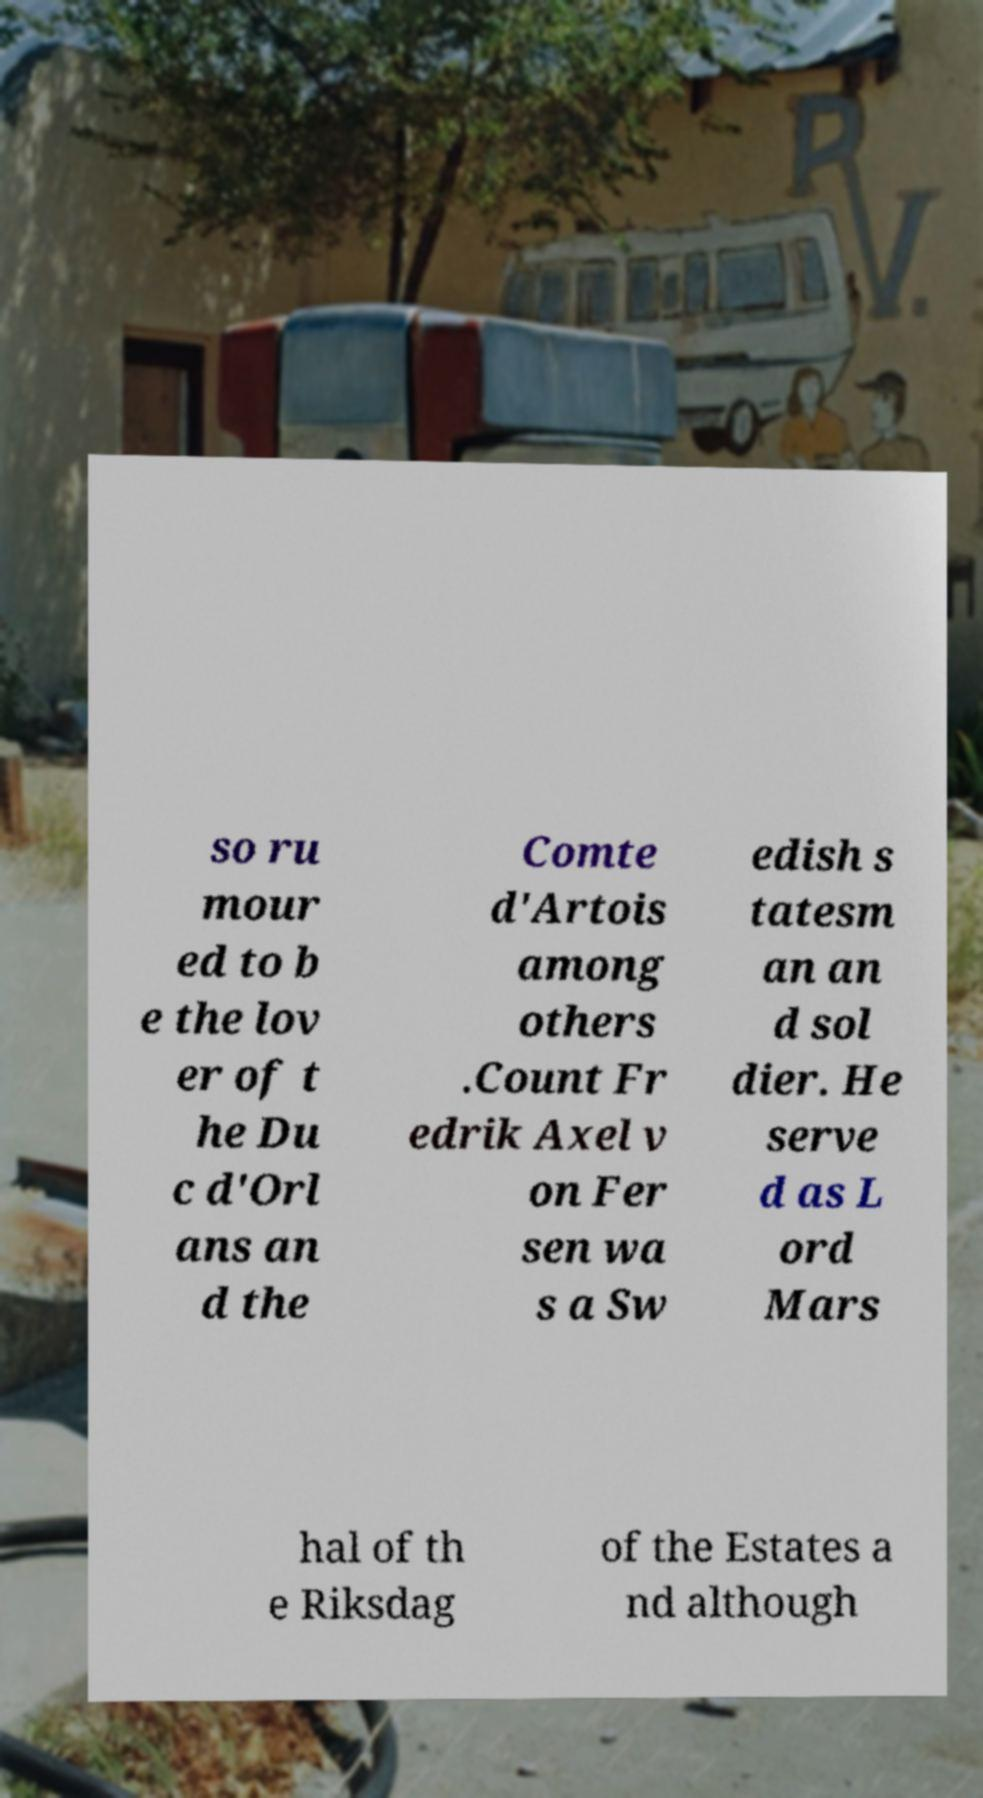Please identify and transcribe the text found in this image. so ru mour ed to b e the lov er of t he Du c d'Orl ans an d the Comte d'Artois among others .Count Fr edrik Axel v on Fer sen wa s a Sw edish s tatesm an an d sol dier. He serve d as L ord Mars hal of th e Riksdag of the Estates a nd although 